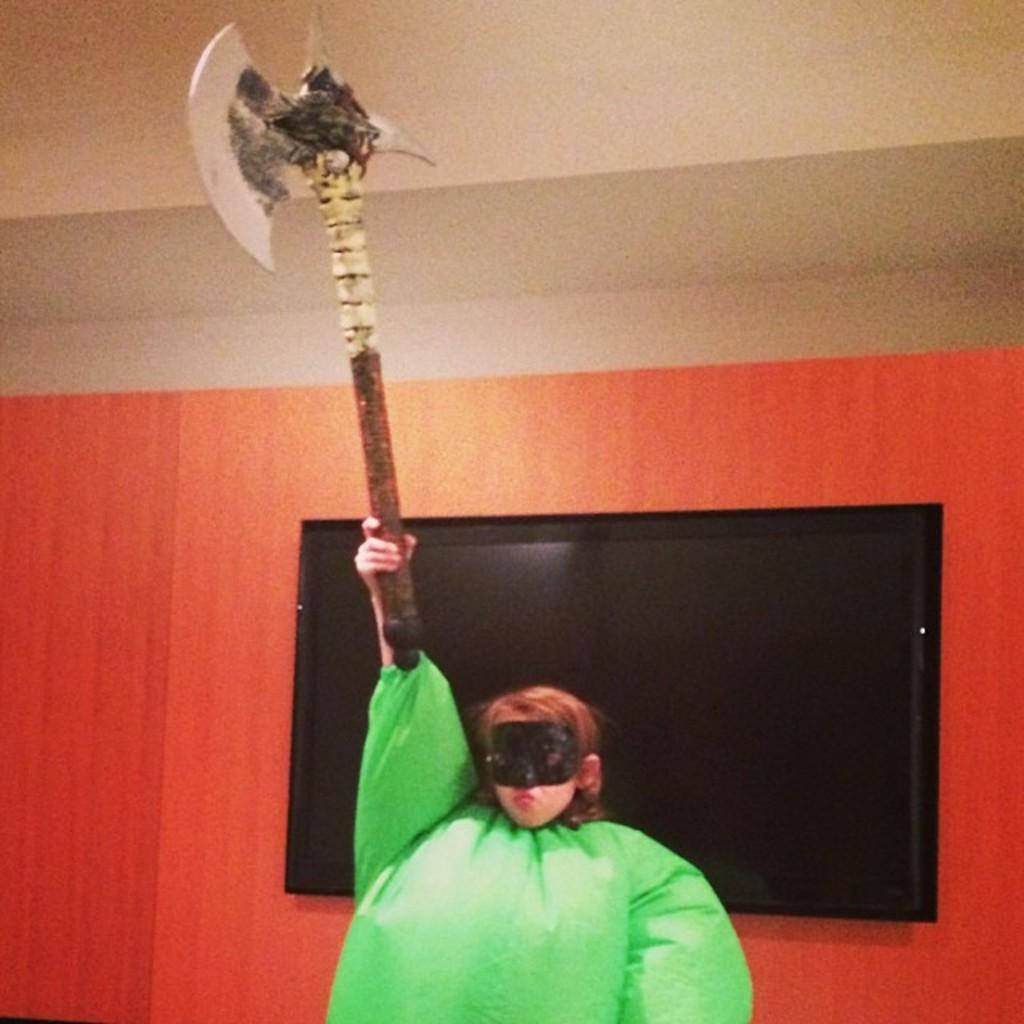Describe this image in one or two sentences. In this image I can see a person holding a weapon. The person is wearing green color dress, background I can see a screen and the wall is in cream and orange color. 